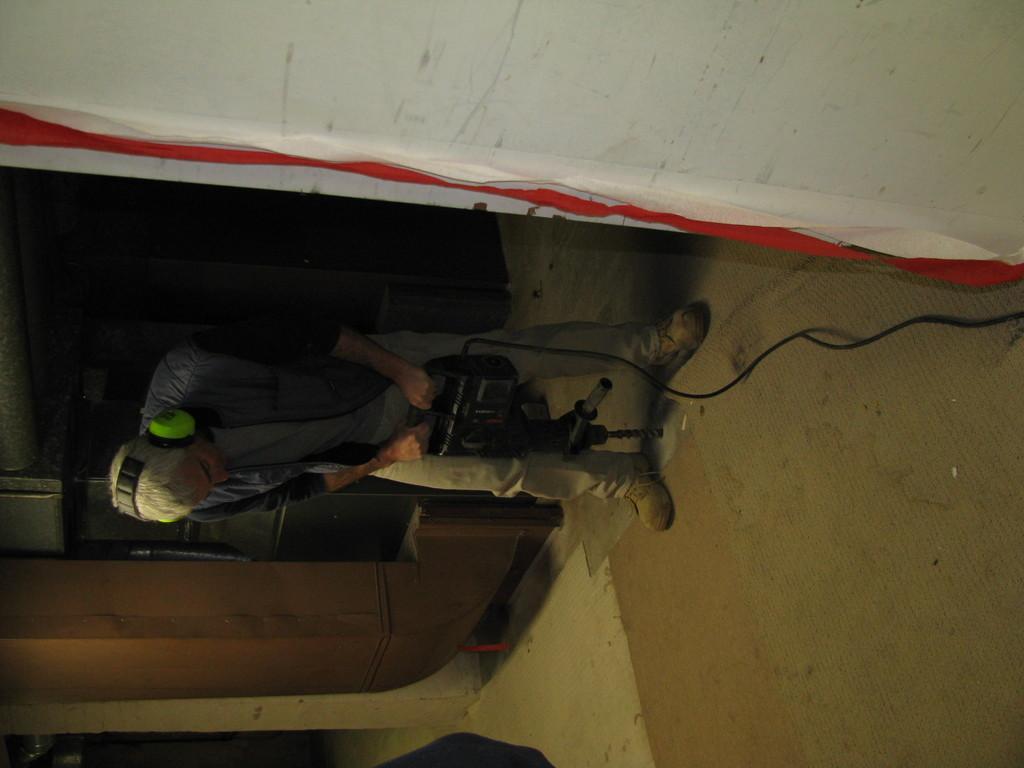Describe this image in one or two sentences. In the image there is a man drilling the floor inside a room,he is wearing the headset and a jacket. 